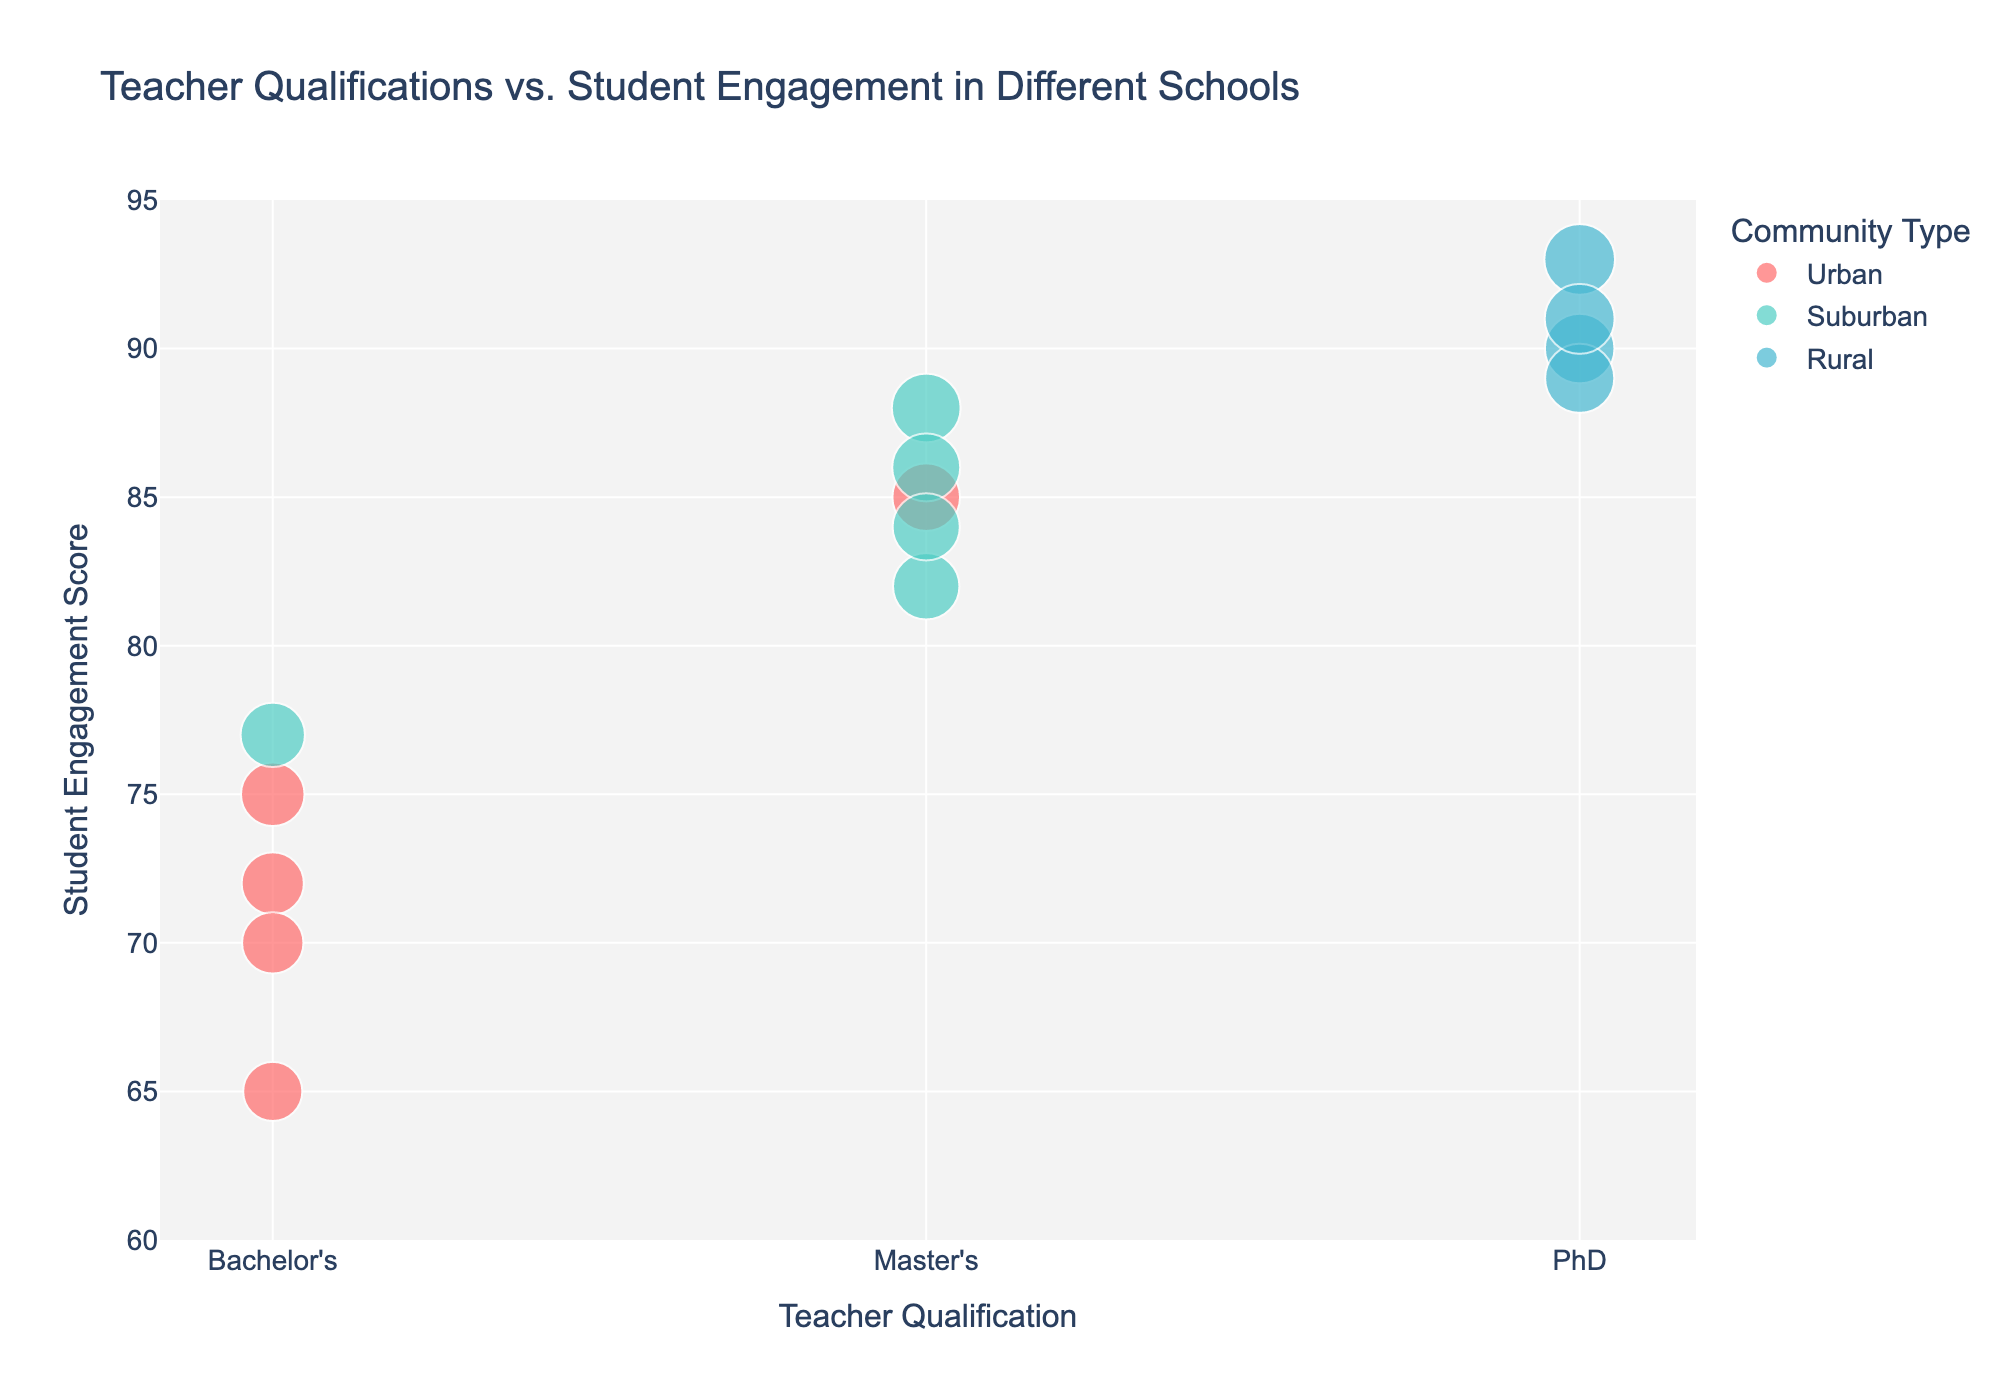How many schools in Urban communities have Bachelor's Degree qualifications? To find this, look for data points colored with the shade representing 'Urban'. Next, check if the 'Teacher Qualification' is 'Bachelor's Degree'. There are three such schools: Lakeside Middle, Greenwood Elementary, and Meadowbrook Middle.
Answer: 3 What is the student engagement score for the school with a PhD qualification in a Suburban community? By examining the scatter plot, there are no data points (PhD qualifications) within Suburban (green) clusters.
Answer: None Which school has the highest student engagement score? Look for the data point that is plotted at the highest position on the y-axis. The topmost point is Pine Valley School, which has a PhD qualification and a student engagement score of 93.
Answer: Pine Valley School What is the difference in student engagement between Springfield Elementary and Redwood Elementary (assuming 'Redwood Elementary' was intended to mean 'Greenwood Elementary')? Locate the data points for Springfield Elementary and Greenwood Elementary. Compare their y-values. Springfield Elementary has a score of 85, and Greenwood Elementary has a score of 65. The difference is 85 − 65.
Answer: 20 Which community type has the most schools with PhD qualifications? Identify the color representing each community type and count the number of points for each community where the teacher qualification is PhD (marked at the x-axis value 3). There are four PhD-qualified schools: Mountainview School, Pine Valley School, Cedar Ridge High, and Oakdale Primary, all in Rural communities.
Answer: Rural Are the student engagement scores generally higher in schools with Master's Degrees or Bachelor's Degrees? Compare the general trends or median values of student engagement scores (y-axis) for points plotted along the x-axis value of 2 (Master's Degrees) and 1 (Bachelor's Degrees). On average, Master's Degree scores appear higher overall.
Answer: Master's Degrees What is the student engagement score for Hillcrest Academy? Locate Hillcrest Academy in the hover data of the plot. Hillcrest Academy, having a Master's Degree qualification, has a reported engagement score of 88.
Answer: 88 How many schools have a student engagement score above 85? Look for points that lie above the y-axis value of 85 across all community types. There are six such schools: Springfield Elementary, Mountainview School, Hillcrest Academy, Pine Valley School, Maplewood High, and Oakdale Primary.
Answer: 6 Which schools have the same student engagement score of 90? View the y-axis and identify the points where student engagement is 90. Mountainview School (PhD, Rural) has a student engagement score of 90.
Answer: Mountainview School 